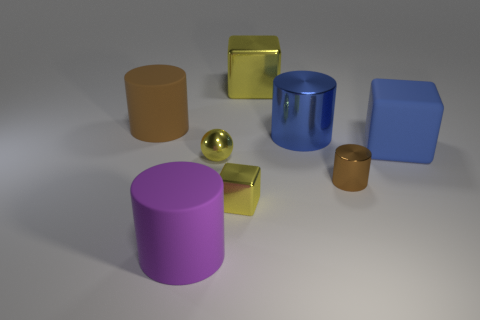Subtract all large blue blocks. How many blocks are left? 2 Subtract all brown blocks. How many brown cylinders are left? 2 Add 1 large purple rubber cylinders. How many objects exist? 9 Subtract 2 cylinders. How many cylinders are left? 2 Subtract all blue cylinders. How many cylinders are left? 3 Subtract all spheres. How many objects are left? 7 Add 1 blue objects. How many blue objects are left? 3 Add 3 large purple cylinders. How many large purple cylinders exist? 4 Subtract 1 yellow spheres. How many objects are left? 7 Subtract all blue cylinders. Subtract all yellow balls. How many cylinders are left? 3 